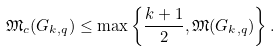Convert formula to latex. <formula><loc_0><loc_0><loc_500><loc_500>\mathfrak { M } _ { c } ( G _ { k , q } ) \leq \max \left \{ \frac { k + 1 } { 2 } , \mathfrak { M } ( G _ { k , q } ) \right \} .</formula> 